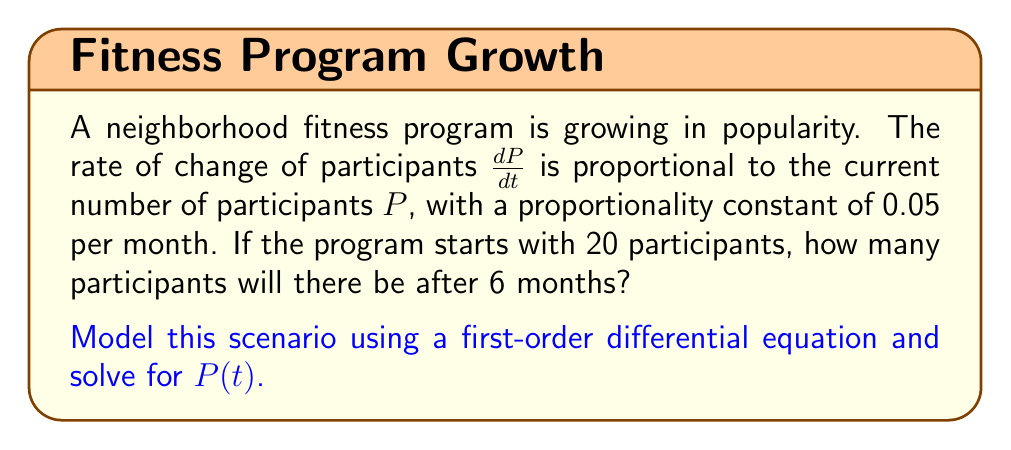Give your solution to this math problem. Let's approach this step-by-step:

1) We're told that the rate of change of participants is proportional to the current number of participants. This can be modeled as:

   $$\frac{dP}{dt} = kP$$

   where $k$ is the proportionality constant.

2) We're given that $k = 0.05$ per month, so our differential equation becomes:

   $$\frac{dP}{dt} = 0.05P$$

3) This is a separable differential equation. Let's separate the variables:

   $$\frac{dP}{P} = 0.05dt$$

4) Integrate both sides:

   $$\int \frac{dP}{P} = \int 0.05dt$$

   $$\ln|P| = 0.05t + C$$

5) Exponentiate both sides:

   $$P = e^{0.05t + C} = e^C \cdot e^{0.05t}$$

6) Let $A = e^C$, then our general solution is:

   $$P(t) = Ae^{0.05t}$$

7) We're told that the program starts with 20 participants, so $P(0) = 20$. Let's use this initial condition:

   $$20 = Ae^{0.05(0)} = A$$

8) Therefore, our particular solution is:

   $$P(t) = 20e^{0.05t}$$

9) To find the number of participants after 6 months, we evaluate $P(6)$:

   $$P(6) = 20e^{0.05(6)} = 20e^{0.3} \approx 26.997$$
Answer: After 6 months, there will be approximately 27 participants in the fitness program. 